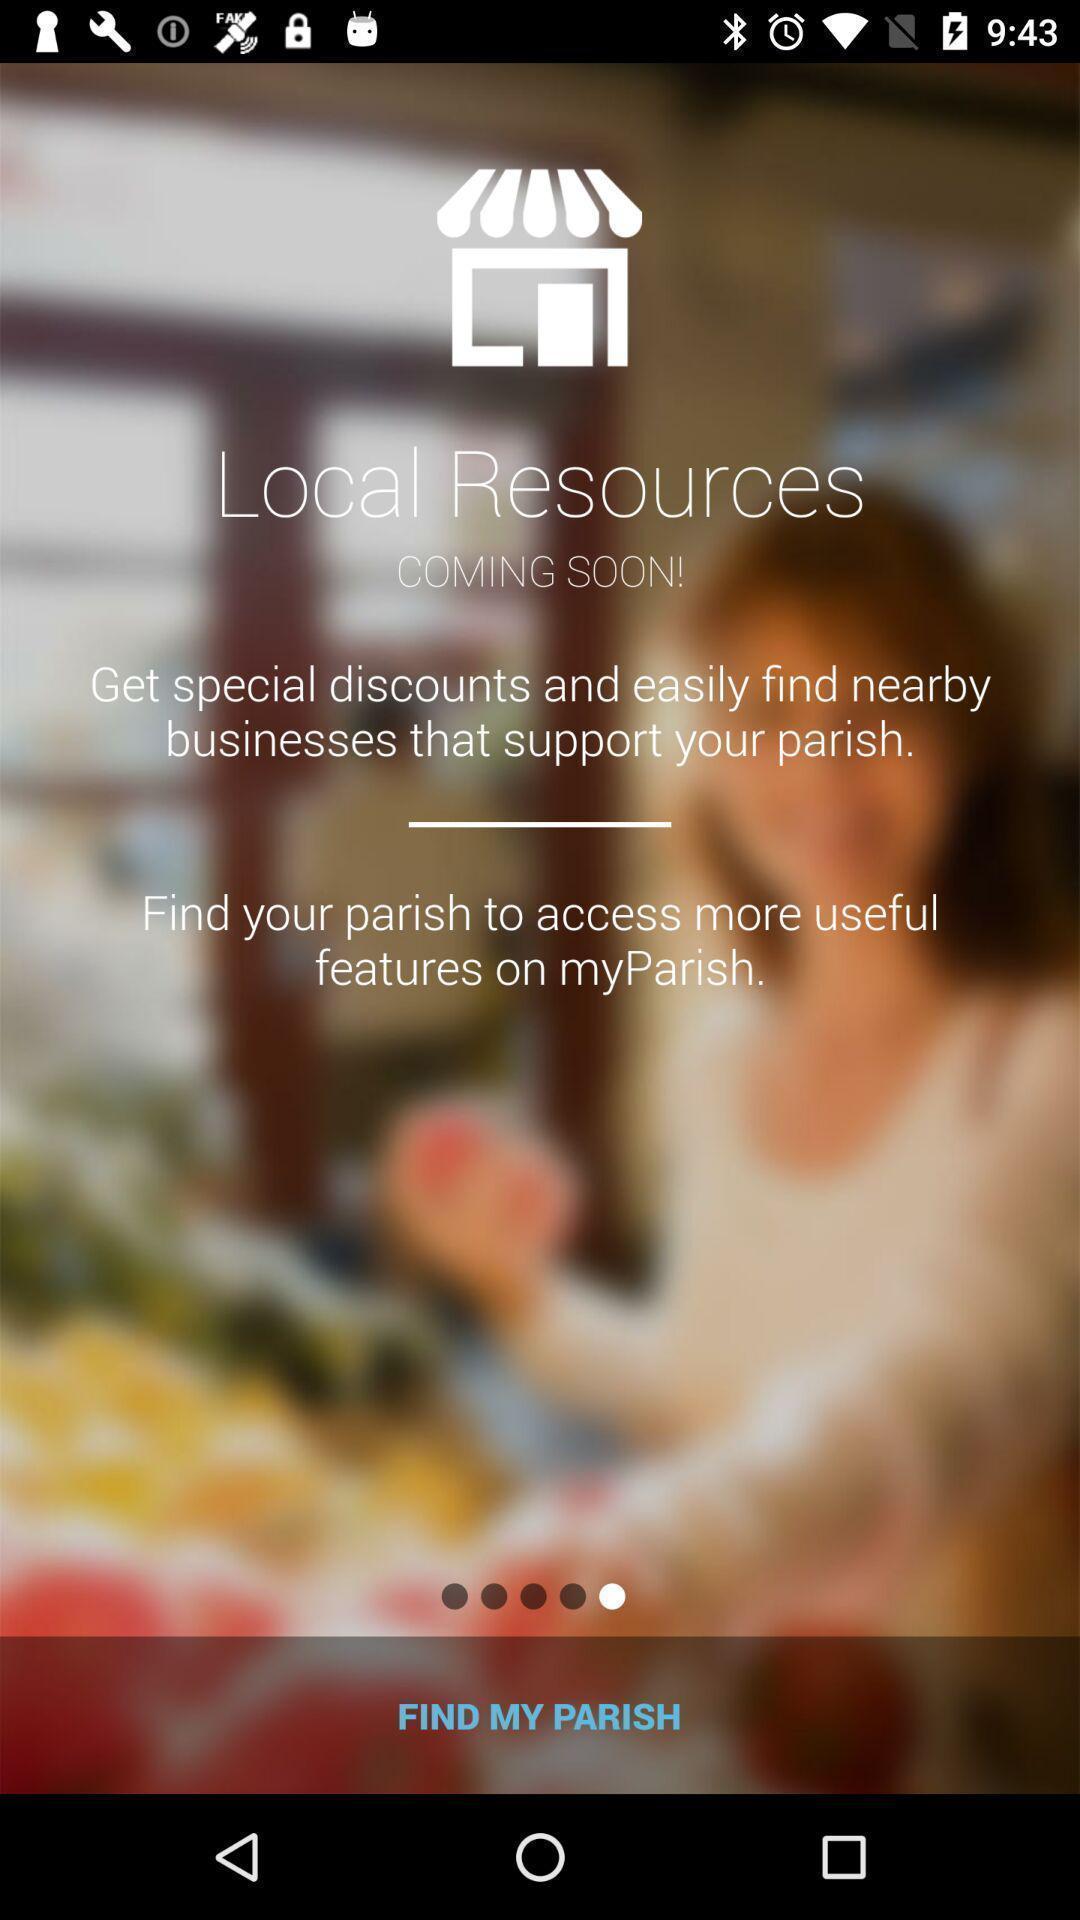Describe the visual elements of this screenshot. Start page. 